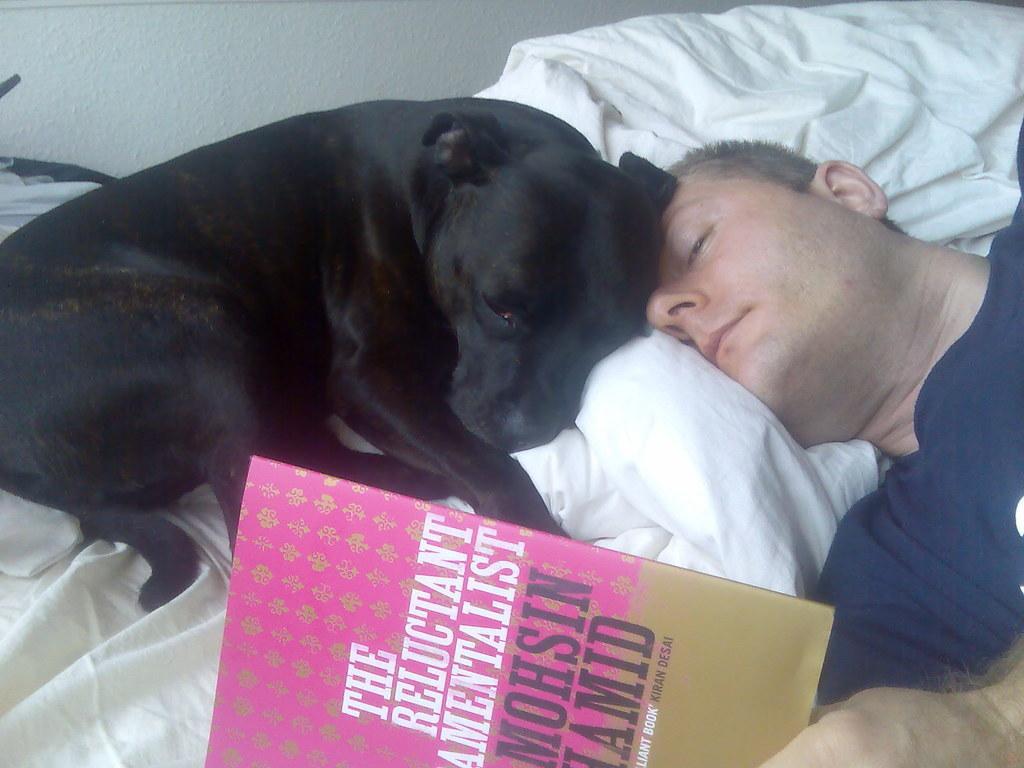How would you summarize this image in a sentence or two? In this picture we can see a man is sleeping on the bed, and here is the book, and dog on it, and at back here is the wall. 